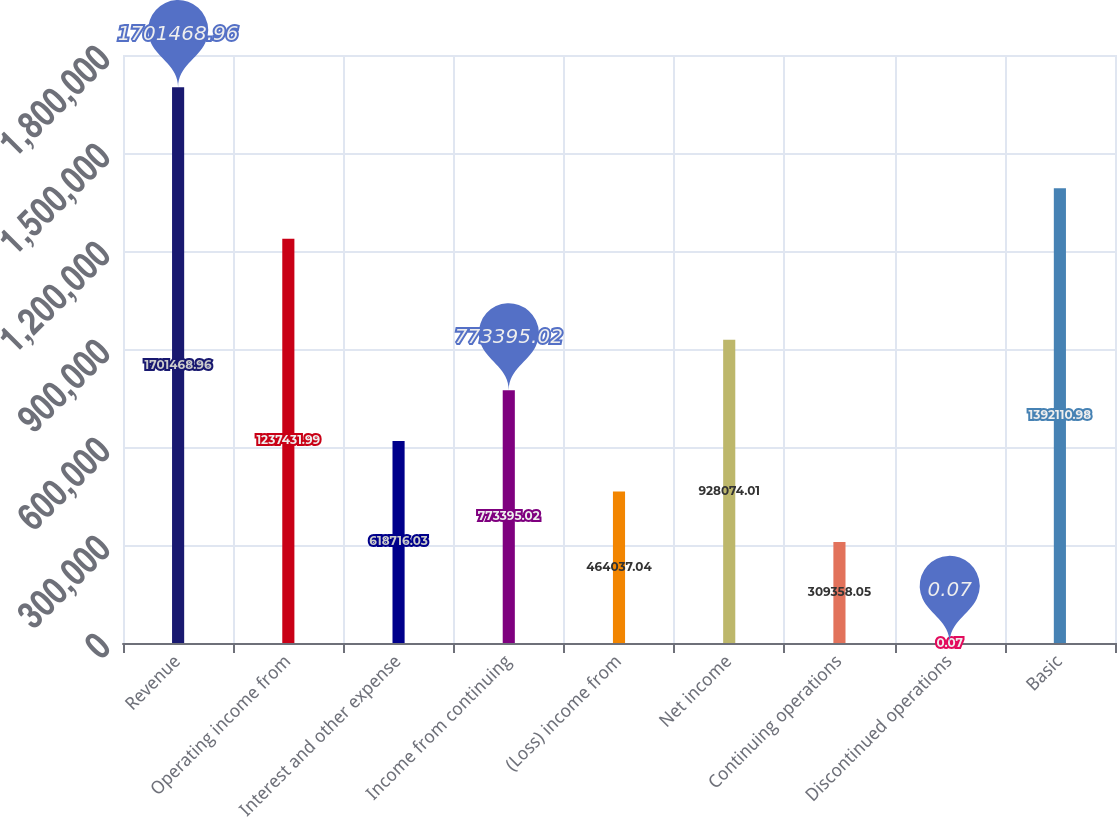Convert chart. <chart><loc_0><loc_0><loc_500><loc_500><bar_chart><fcel>Revenue<fcel>Operating income from<fcel>Interest and other expense<fcel>Income from continuing<fcel>(Loss) income from<fcel>Net income<fcel>Continuing operations<fcel>Discontinued operations<fcel>Basic<nl><fcel>1.70147e+06<fcel>1.23743e+06<fcel>618716<fcel>773395<fcel>464037<fcel>928074<fcel>309358<fcel>0.07<fcel>1.39211e+06<nl></chart> 